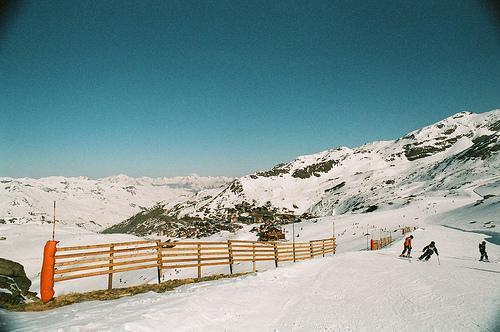How many people are there?
Give a very brief answer. 3. How many people are holding ski poles?
Give a very brief answer. 1. 